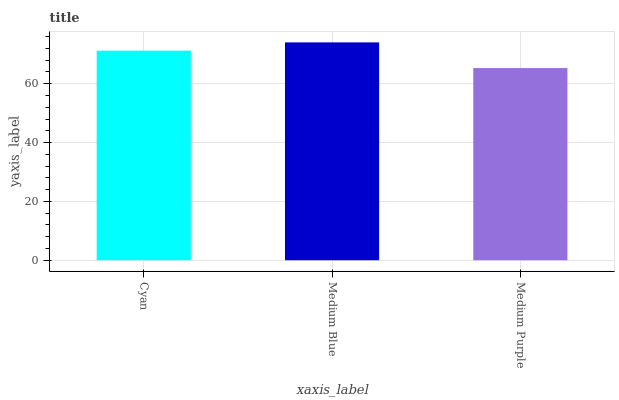Is Medium Blue the minimum?
Answer yes or no. No. Is Medium Purple the maximum?
Answer yes or no. No. Is Medium Blue greater than Medium Purple?
Answer yes or no. Yes. Is Medium Purple less than Medium Blue?
Answer yes or no. Yes. Is Medium Purple greater than Medium Blue?
Answer yes or no. No. Is Medium Blue less than Medium Purple?
Answer yes or no. No. Is Cyan the high median?
Answer yes or no. Yes. Is Cyan the low median?
Answer yes or no. Yes. Is Medium Blue the high median?
Answer yes or no. No. Is Medium Purple the low median?
Answer yes or no. No. 